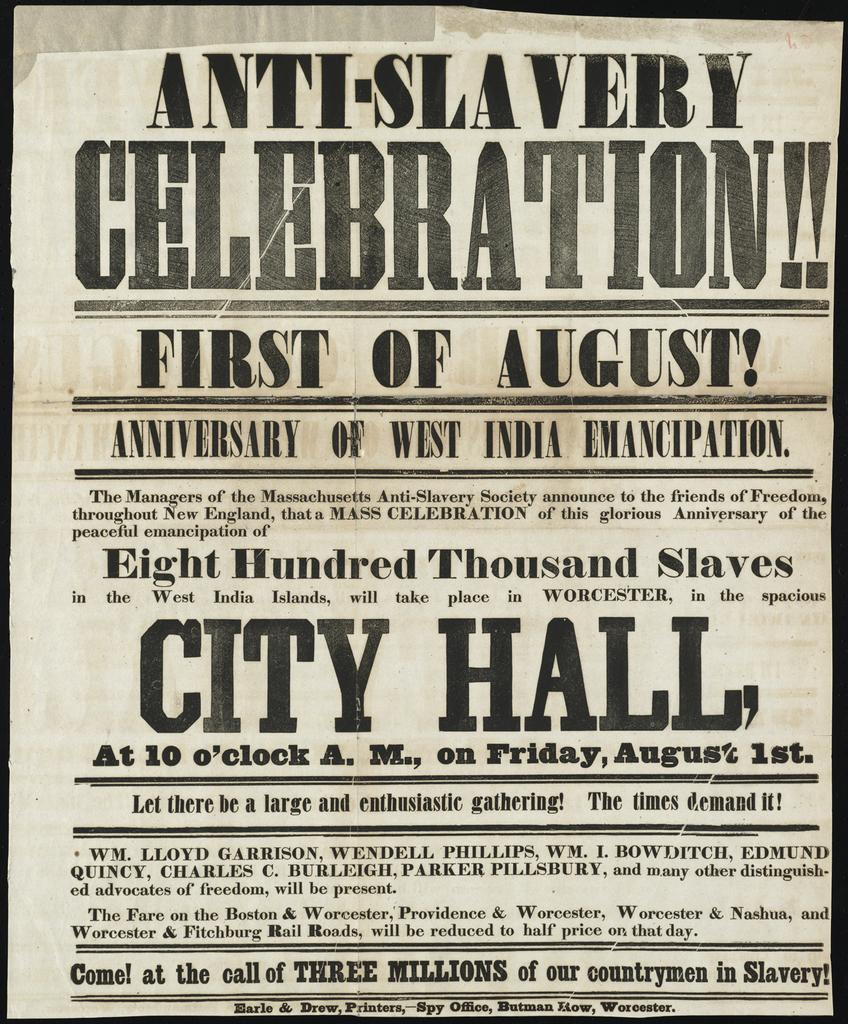<image>
Give a short and clear explanation of the subsequent image. An newspaper advertising an anti-slavery celebration for the first of August. 